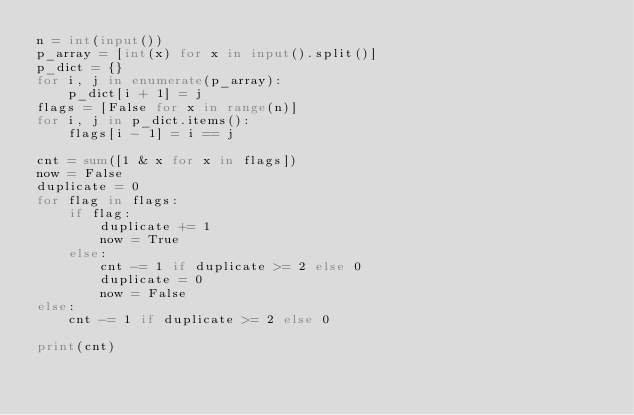<code> <loc_0><loc_0><loc_500><loc_500><_Python_>n = int(input())
p_array = [int(x) for x in input().split()]
p_dict = {}
for i, j in enumerate(p_array):
    p_dict[i + 1] = j
flags = [False for x in range(n)]
for i, j in p_dict.items():
    flags[i - 1] = i == j

cnt = sum([1 & x for x in flags])
now = False
duplicate = 0
for flag in flags:
    if flag:
        duplicate += 1
        now = True
    else:
        cnt -= 1 if duplicate >= 2 else 0
        duplicate = 0
        now = False
else:
    cnt -= 1 if duplicate >= 2 else 0

print(cnt)
</code> 